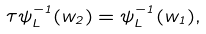Convert formula to latex. <formula><loc_0><loc_0><loc_500><loc_500>\tau \psi _ { L } ^ { - 1 } ( w _ { 2 } ) = \psi _ { L } ^ { - 1 } ( w _ { 1 } ) ,</formula> 